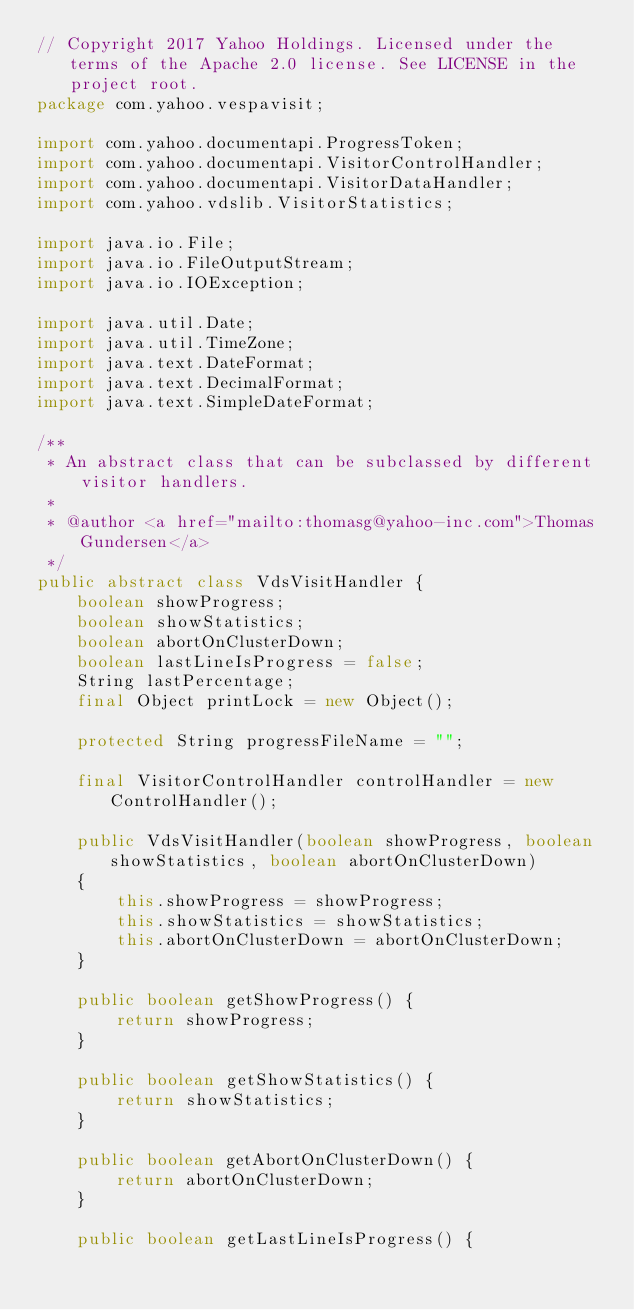<code> <loc_0><loc_0><loc_500><loc_500><_Java_>// Copyright 2017 Yahoo Holdings. Licensed under the terms of the Apache 2.0 license. See LICENSE in the project root.
package com.yahoo.vespavisit;

import com.yahoo.documentapi.ProgressToken;
import com.yahoo.documentapi.VisitorControlHandler;
import com.yahoo.documentapi.VisitorDataHandler;
import com.yahoo.vdslib.VisitorStatistics;

import java.io.File;
import java.io.FileOutputStream;
import java.io.IOException;

import java.util.Date;
import java.util.TimeZone;
import java.text.DateFormat;
import java.text.DecimalFormat;
import java.text.SimpleDateFormat;

/**
 * An abstract class that can be subclassed by different visitor handlers.
 *
 * @author <a href="mailto:thomasg@yahoo-inc.com">Thomas Gundersen</a>
 */
public abstract class VdsVisitHandler {
    boolean showProgress;
    boolean showStatistics;
    boolean abortOnClusterDown;
    boolean lastLineIsProgress = false;
    String lastPercentage;
    final Object printLock = new Object();

    protected String progressFileName = "";

    final VisitorControlHandler controlHandler = new ControlHandler();

    public VdsVisitHandler(boolean showProgress, boolean showStatistics, boolean abortOnClusterDown)
    {
        this.showProgress = showProgress;
        this.showStatistics = showStatistics;
        this.abortOnClusterDown = abortOnClusterDown;
    }

    public boolean getShowProgress() {
        return showProgress;
    }

    public boolean getShowStatistics() {
        return showStatistics;
    }

    public boolean getAbortOnClusterDown() {
        return abortOnClusterDown;
    }

    public boolean getLastLineIsProgress() {</code> 